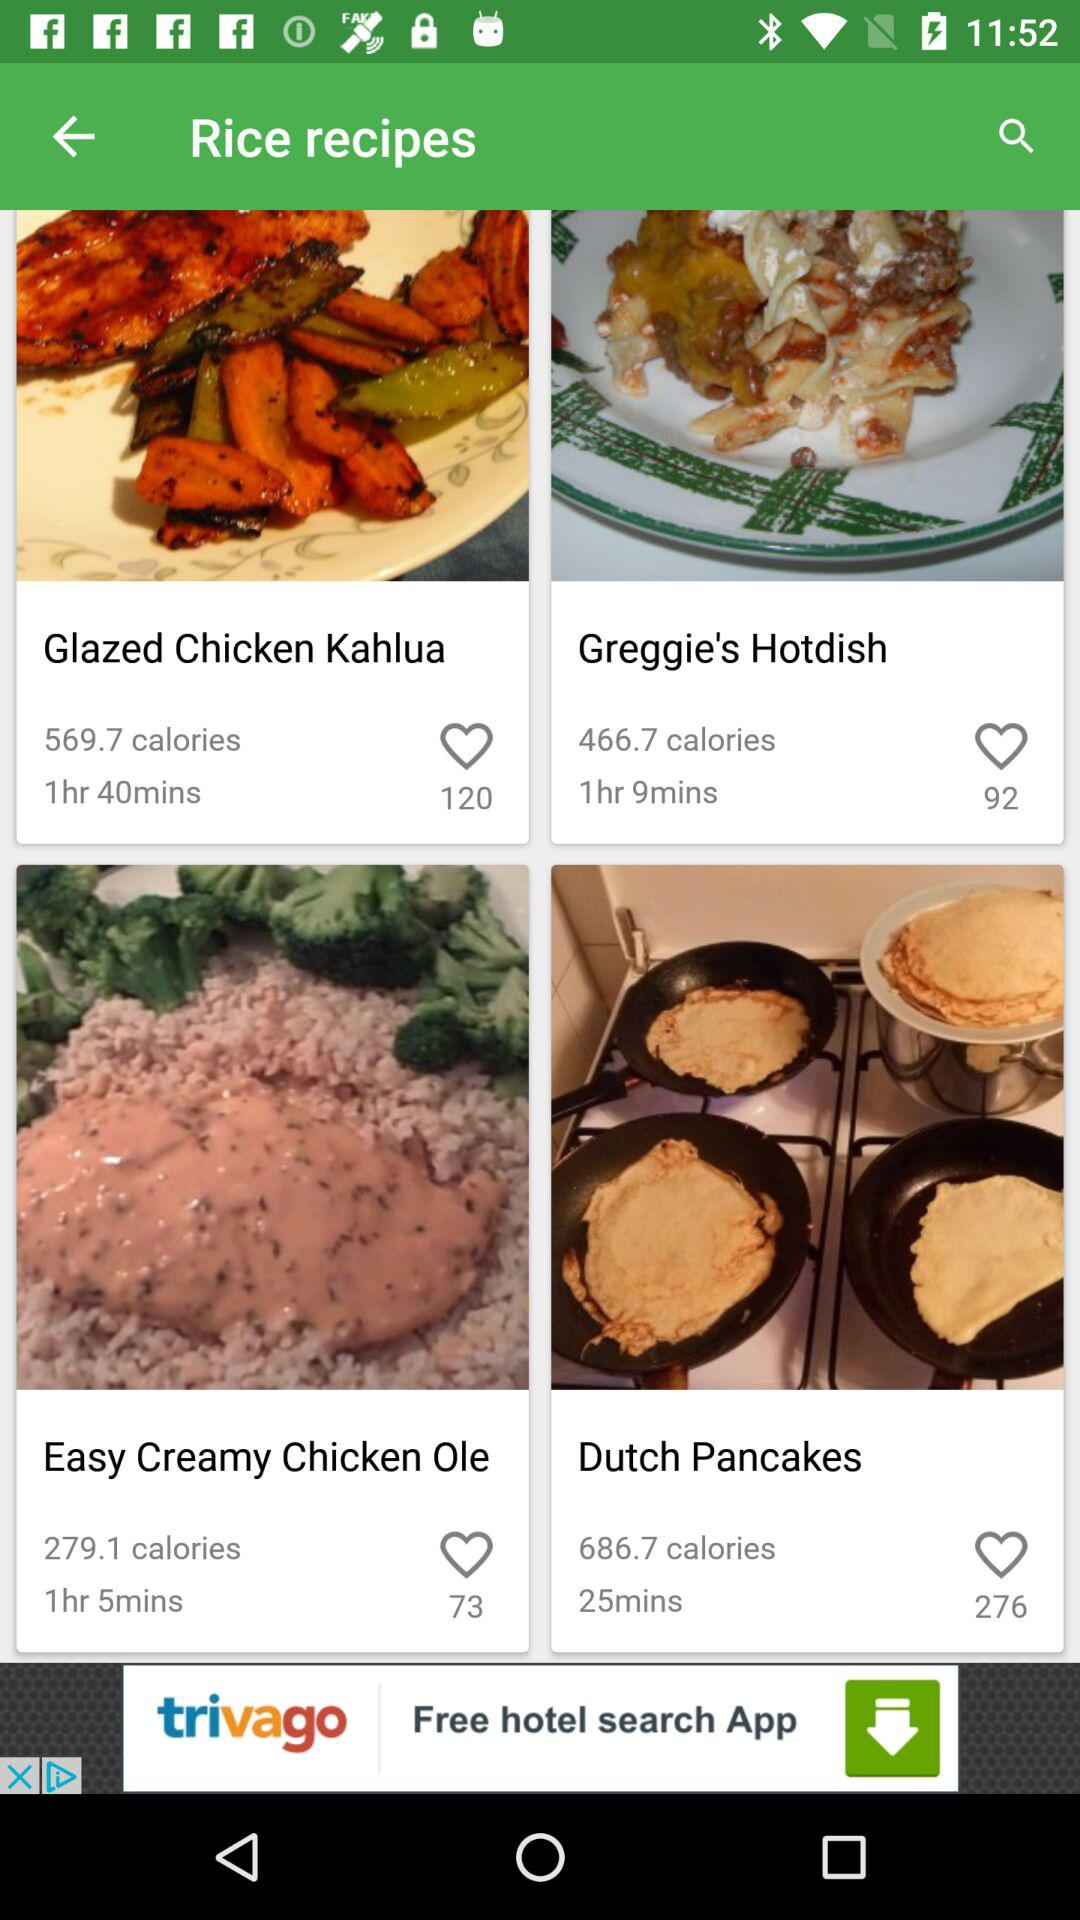What is the amount of calories in "Dutch Pancakes"? The amount of calories in "Dutch Pancakes" is 686.7. 